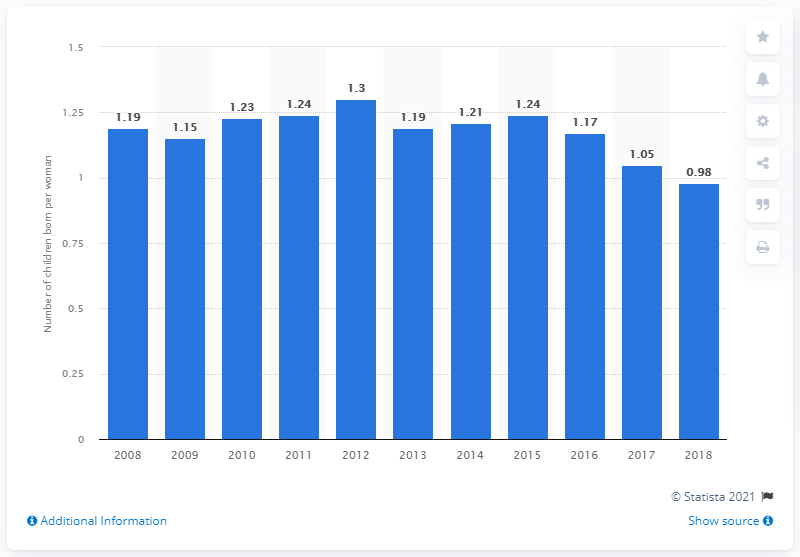Give some essential details in this illustration. The fertility rate in South Korea in 2018 was 0.98. 